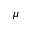<formula> <loc_0><loc_0><loc_500><loc_500>\mu</formula> 